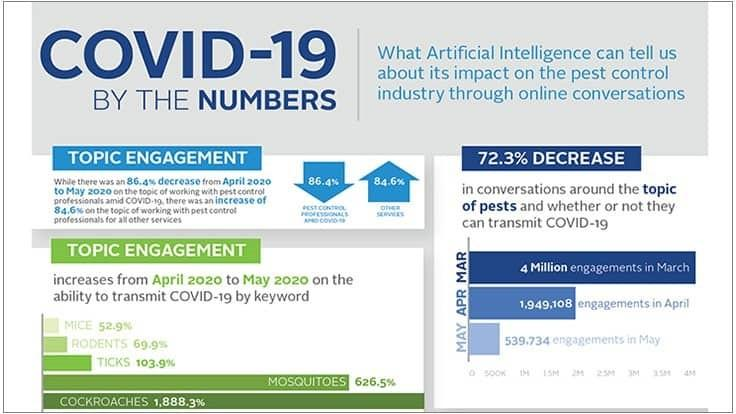Specify some key components in this picture. The engagement has been second least in April. The two pests that generated the most discussion in their ability to transmit COVID-19 were mosquitoes and cockroaches. In April and May, there is a difference in engagements of 140,9374... 